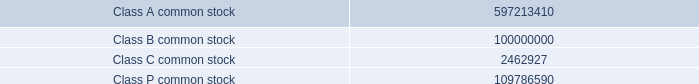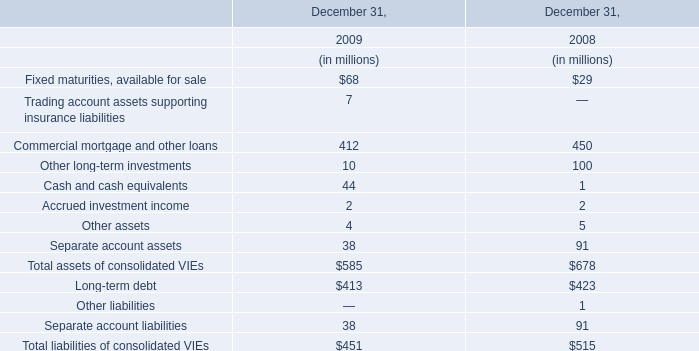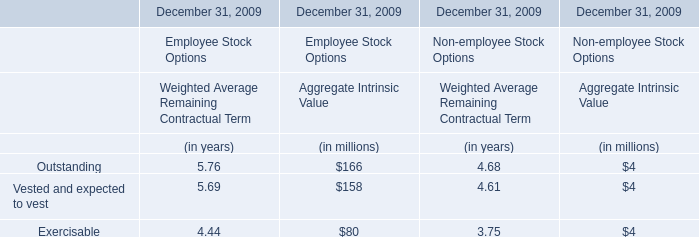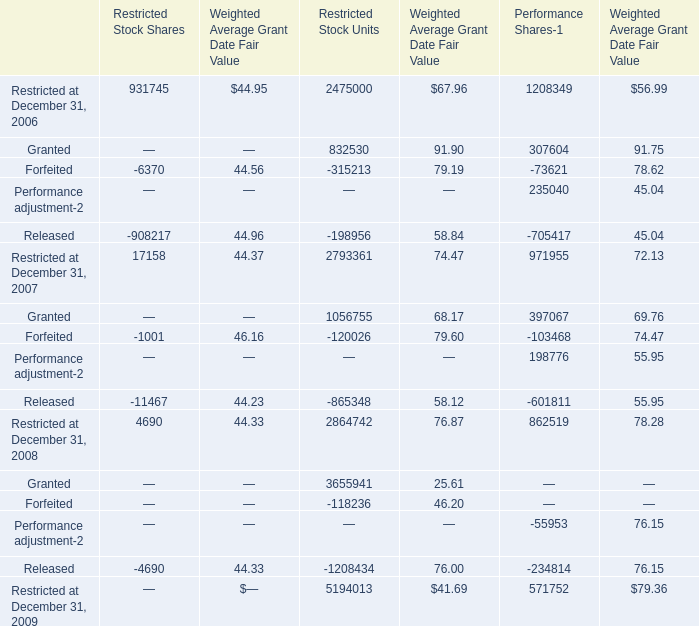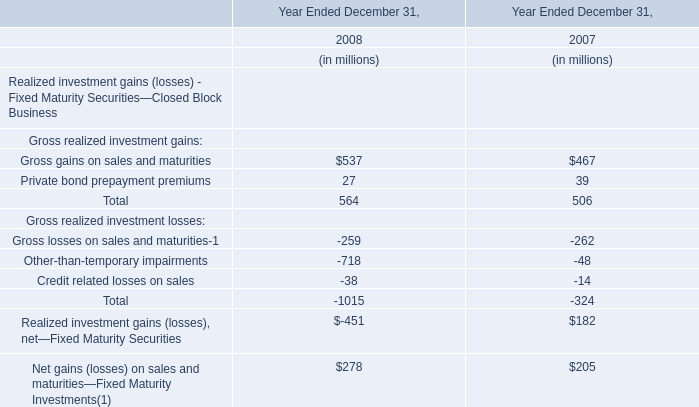What's the average of Released of Restricted Stock Shares, and Class A common stock ? 
Computations: ((908217.0 + 597213410.0) / 2)
Answer: 299060813.5. 